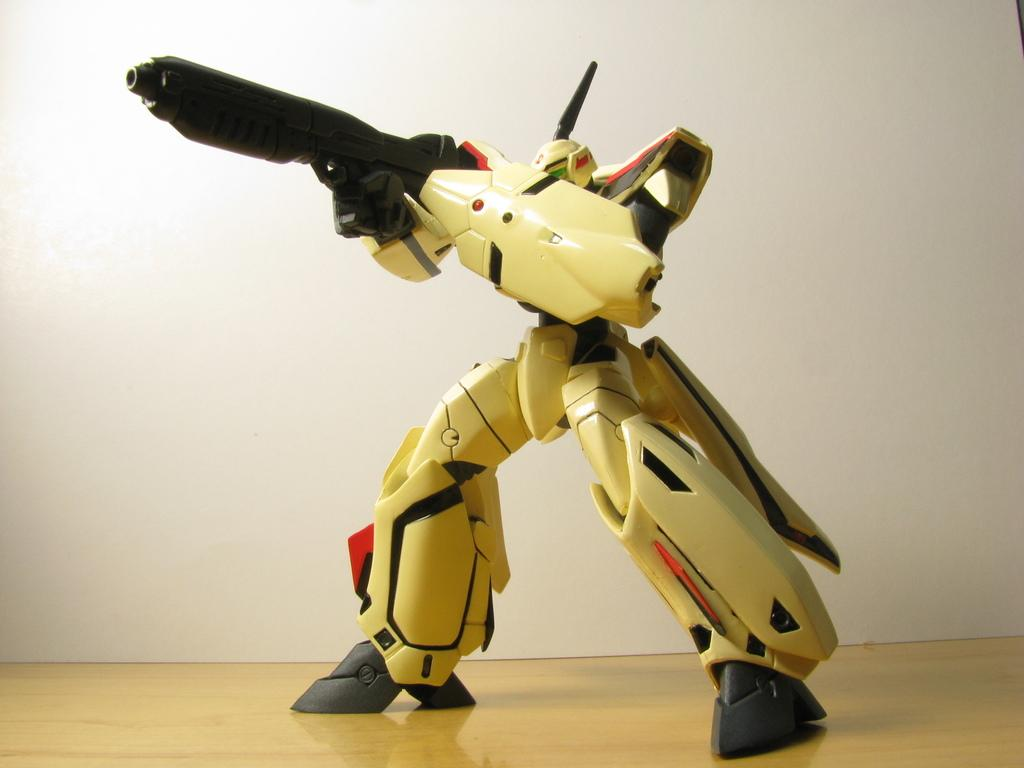What type of toy is in the image? There is a person toy in the image. What is the person toy holding? The person toy is holding a gun. Where is the person toy located? The person toy is on the floor. What can be seen in the background of the image? There is a wall in the background of the image. What type of haircut does the person toy have in the image? There is no information about the person toy's haircut in the image. Can you tell me if the person toy is standing on the roof in the image? There is no roof visible in the image, and the person toy is on the floor. 